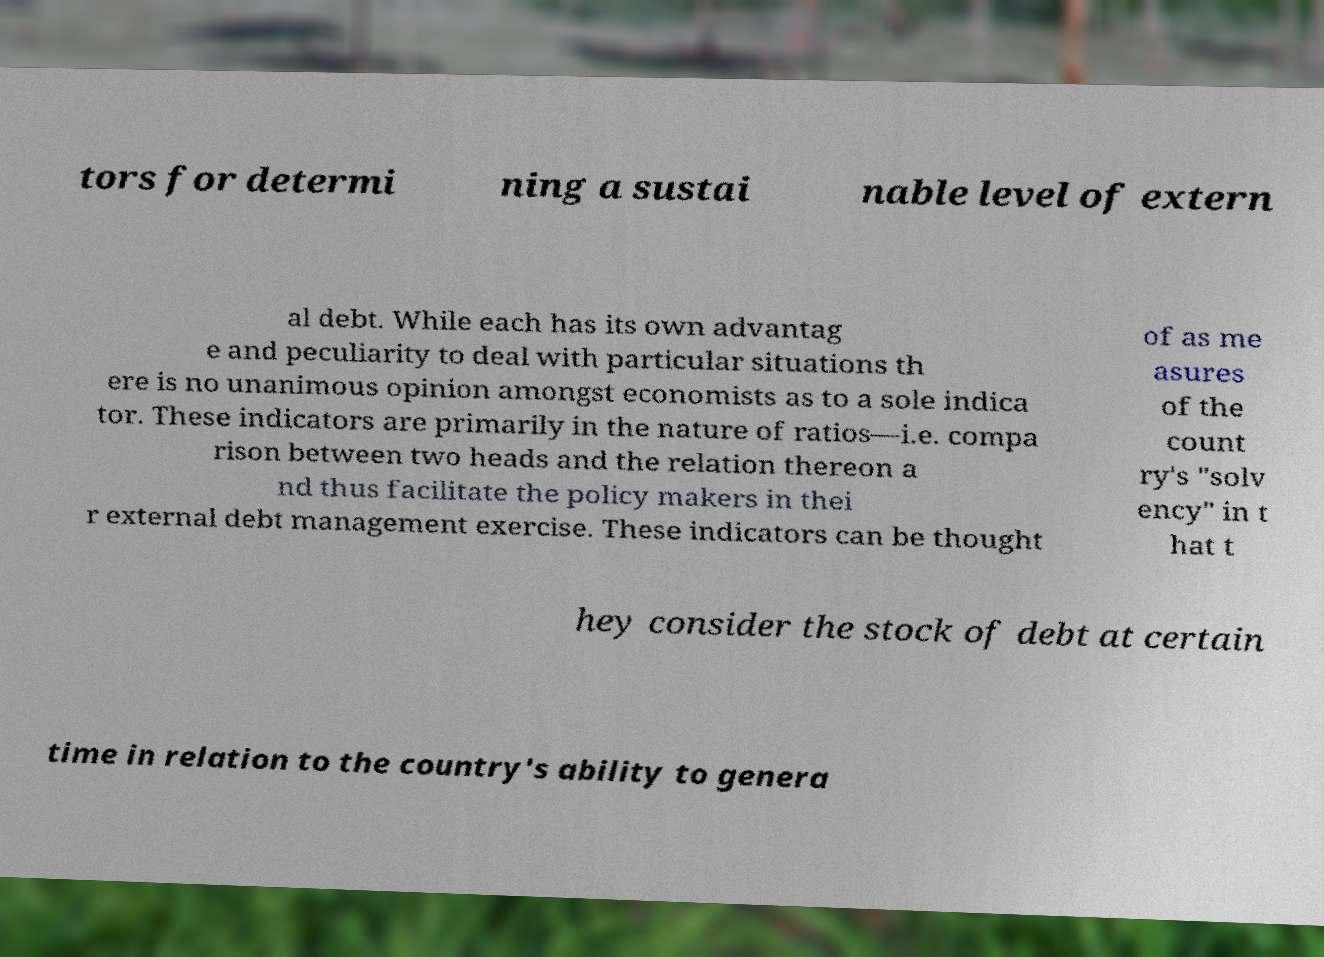For documentation purposes, I need the text within this image transcribed. Could you provide that? tors for determi ning a sustai nable level of extern al debt. While each has its own advantag e and peculiarity to deal with particular situations th ere is no unanimous opinion amongst economists as to a sole indica tor. These indicators are primarily in the nature of ratios—i.e. compa rison between two heads and the relation thereon a nd thus facilitate the policy makers in thei r external debt management exercise. These indicators can be thought of as me asures of the count ry's "solv ency" in t hat t hey consider the stock of debt at certain time in relation to the country's ability to genera 